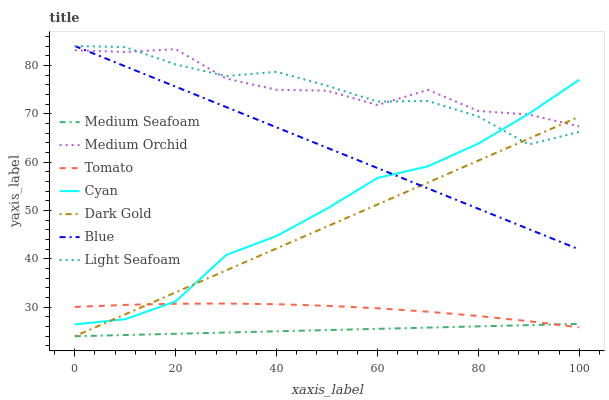Does Medium Seafoam have the minimum area under the curve?
Answer yes or no. Yes. Does Medium Orchid have the maximum area under the curve?
Answer yes or no. Yes. Does Blue have the minimum area under the curve?
Answer yes or no. No. Does Blue have the maximum area under the curve?
Answer yes or no. No. Is Medium Seafoam the smoothest?
Answer yes or no. Yes. Is Medium Orchid the roughest?
Answer yes or no. Yes. Is Blue the smoothest?
Answer yes or no. No. Is Blue the roughest?
Answer yes or no. No. Does Dark Gold have the lowest value?
Answer yes or no. Yes. Does Blue have the lowest value?
Answer yes or no. No. Does Light Seafoam have the highest value?
Answer yes or no. Yes. Does Dark Gold have the highest value?
Answer yes or no. No. Is Medium Seafoam less than Medium Orchid?
Answer yes or no. Yes. Is Cyan greater than Medium Seafoam?
Answer yes or no. Yes. Does Medium Orchid intersect Cyan?
Answer yes or no. Yes. Is Medium Orchid less than Cyan?
Answer yes or no. No. Is Medium Orchid greater than Cyan?
Answer yes or no. No. Does Medium Seafoam intersect Medium Orchid?
Answer yes or no. No. 